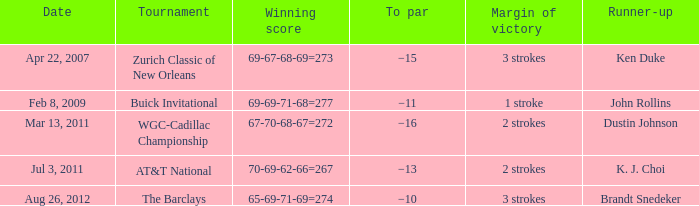In the event where the margin of victory was 2 strokes and the to par was -16, who came in as the runner-up? Dustin Johnson. 